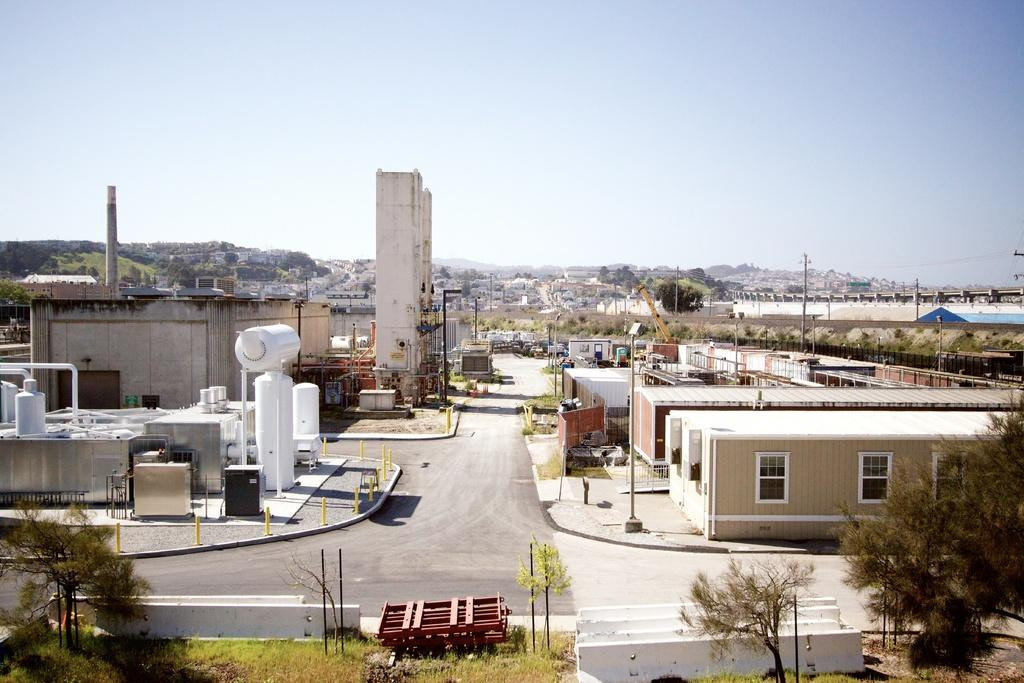What is the main feature of the image? There is a road in the image. What type of structures can be seen along the road? There are buildings with windows in the image. What other natural elements are present in the image? There are trees and grass in the image. What man-made objects can be seen in the image? There are poles in the image. What is visible in the background of the image? The sky is visible in the background of the image. How many prisoners are visible in the image? There are no prisoners or jail in the image. What is the weight of the card on the pole in the image? There is no card present in the image, so its weight cannot be determined. 